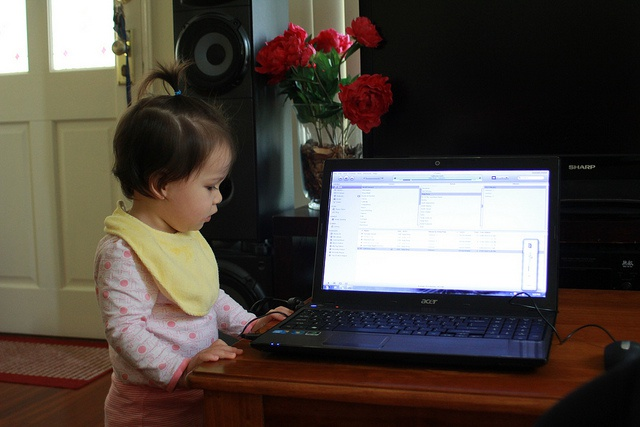Describe the objects in this image and their specific colors. I can see tv in white, black, maroon, and gray tones, laptop in white, black, navy, and darkblue tones, people in white, black, darkgray, maroon, and gray tones, tv in white, black, lavender, and lightblue tones, and potted plant in white, black, maroon, gray, and brown tones in this image. 